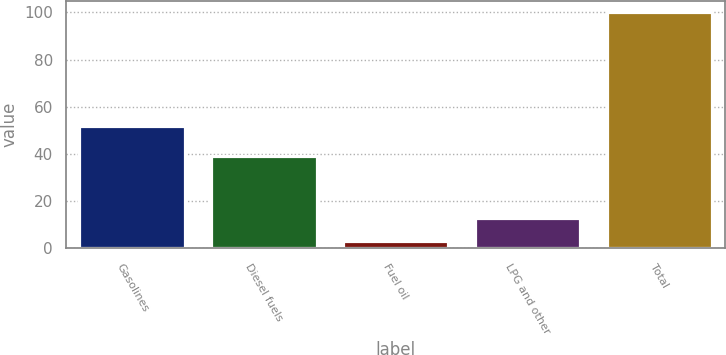Convert chart to OTSL. <chart><loc_0><loc_0><loc_500><loc_500><bar_chart><fcel>Gasolines<fcel>Diesel fuels<fcel>Fuel oil<fcel>LPG and other<fcel>Total<nl><fcel>52<fcel>39<fcel>3<fcel>12.7<fcel>100<nl></chart> 